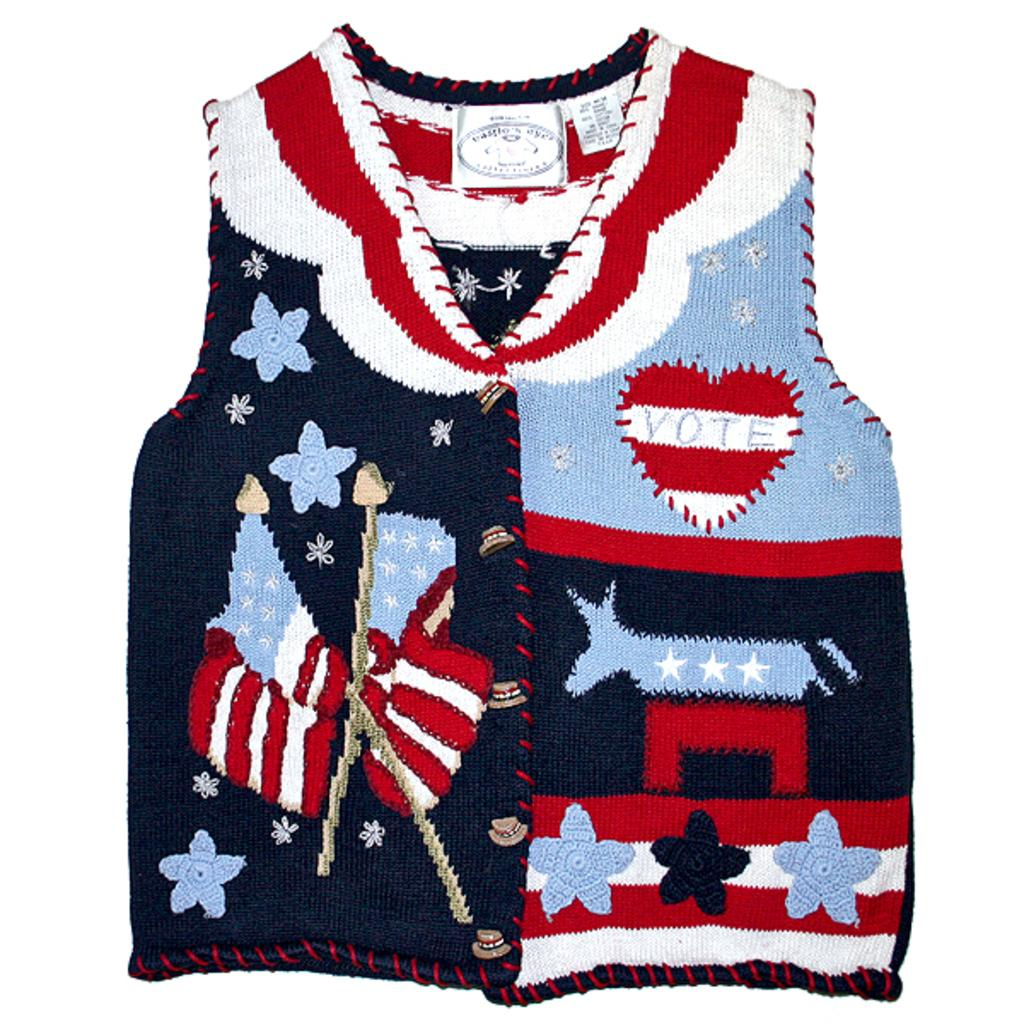<image>
Present a compact description of the photo's key features. A knitted vest has the word "vote" in a heart on the chest. 